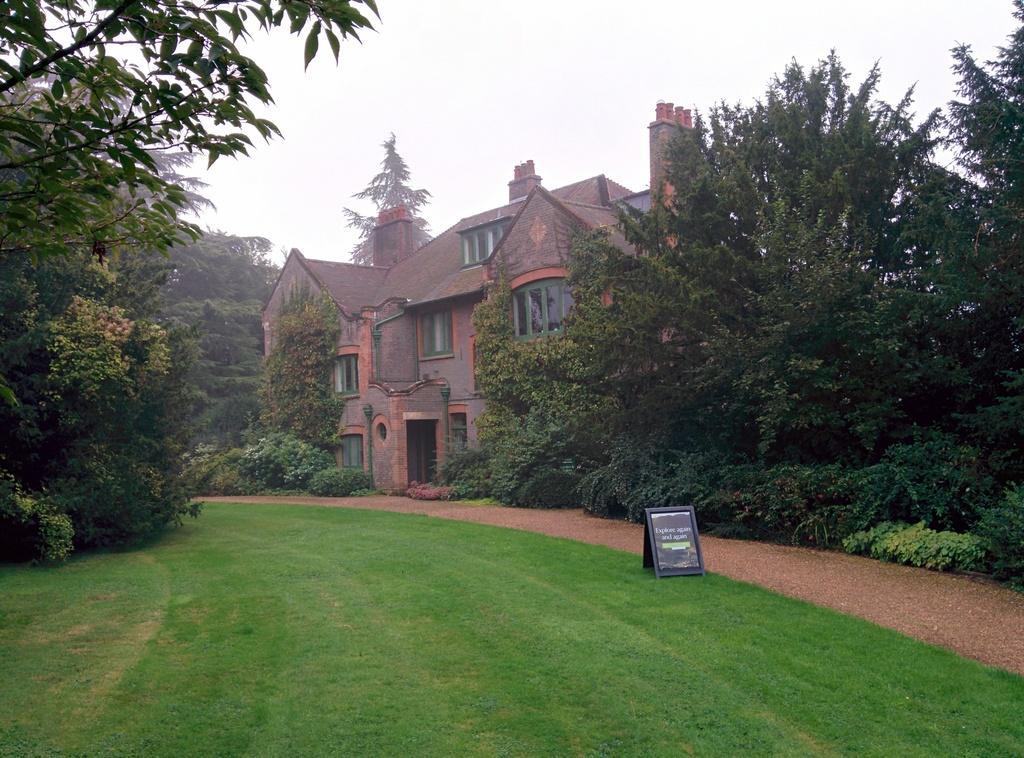Can you describe this image briefly? In this picture, we can see buildings with windows, doors, and we can see ground with grass, trees, poster, plants and the trees, and we can see the sky. 